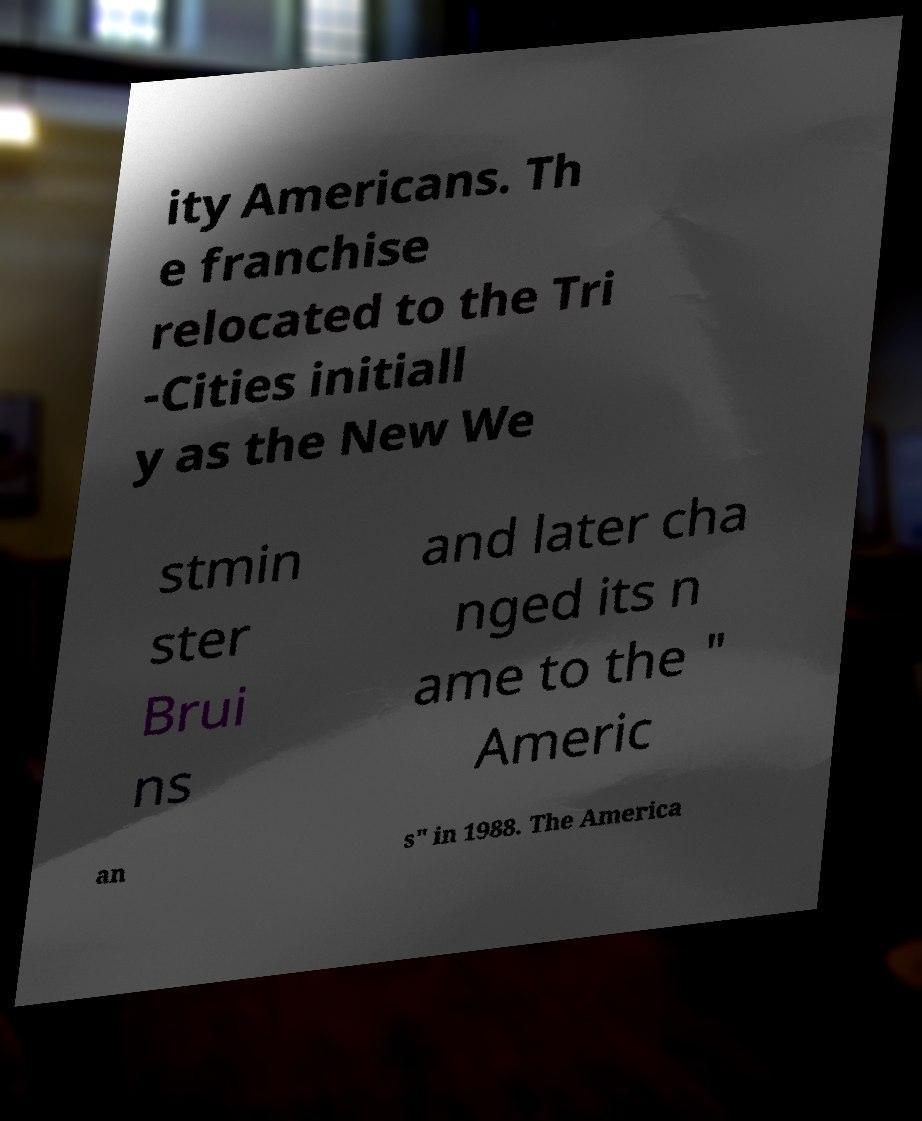Could you extract and type out the text from this image? ity Americans. Th e franchise relocated to the Tri -Cities initiall y as the New We stmin ster Brui ns and later cha nged its n ame to the " Americ an s" in 1988. The America 